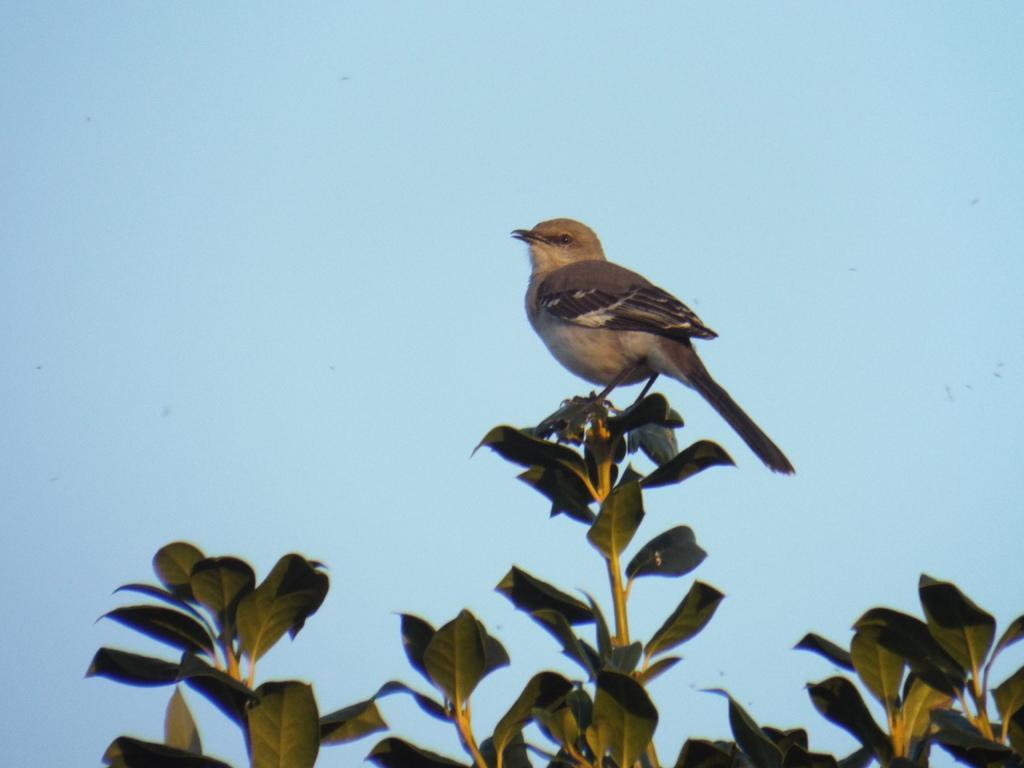How would you summarize this image in a sentence or two? In the image I can see a bird which is on the tree stem. 